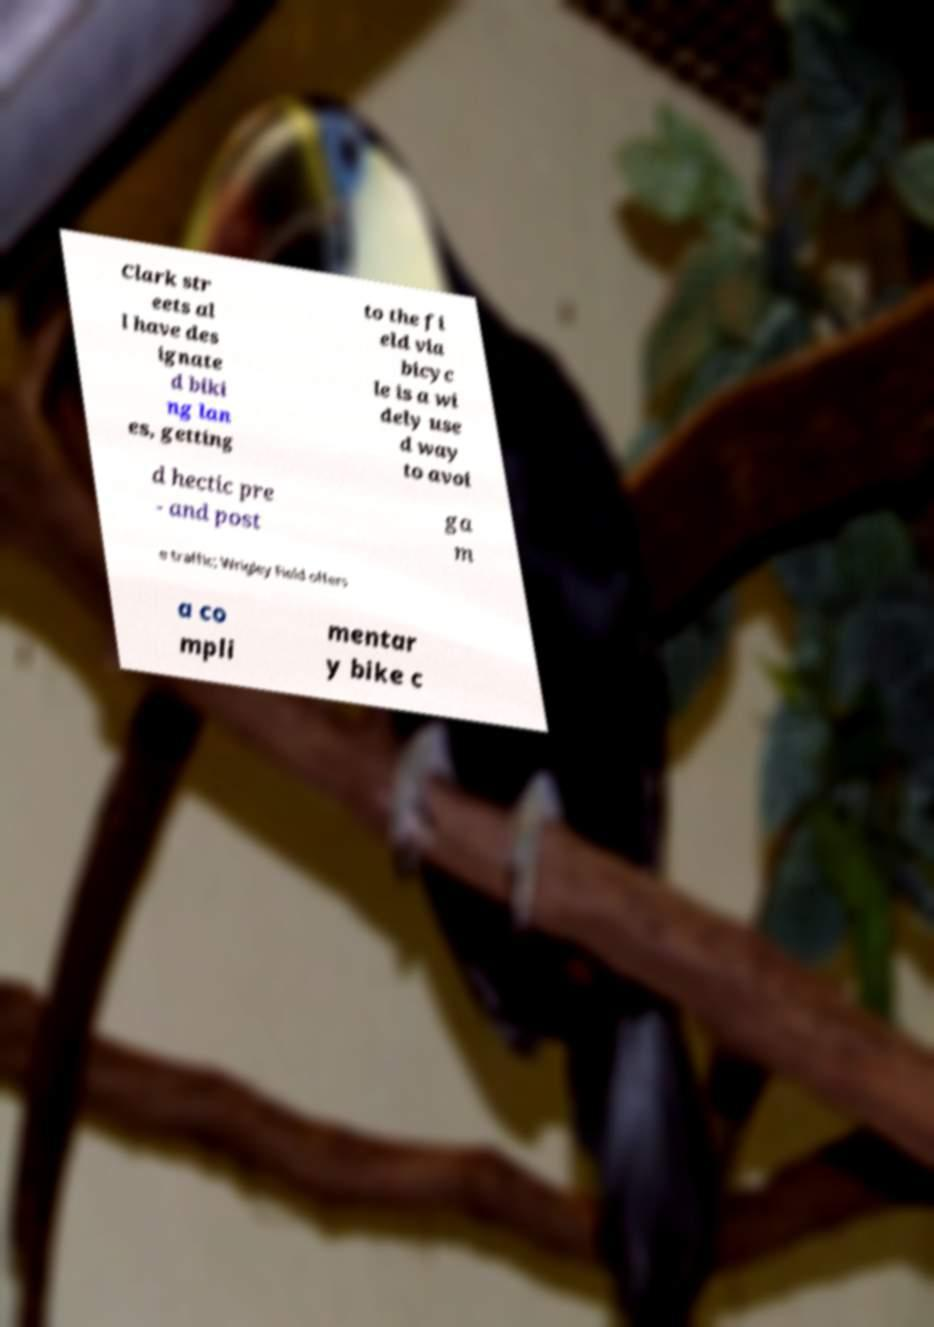There's text embedded in this image that I need extracted. Can you transcribe it verbatim? Clark str eets al l have des ignate d biki ng lan es, getting to the fi eld via bicyc le is a wi dely use d way to avoi d hectic pre - and post ga m e traffic; Wrigley Field offers a co mpli mentar y bike c 